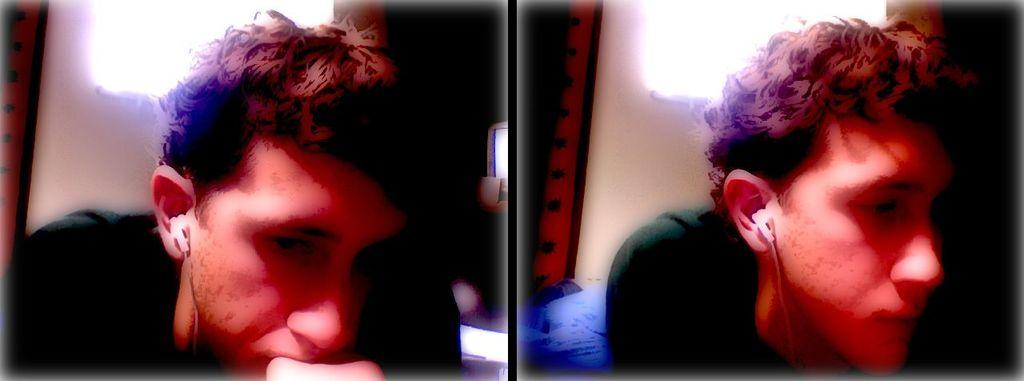How many images are combined to create the collage? The image is a collage of two images. Can you identify the person in the collage? The same person appears in both images. Where is the person located in each image? The person is on the left side of one image and on the right side of the other image. What drug is the person taking in the image? There is no indication of any drug use in the image; it only shows the person in two different locations within the collage. 